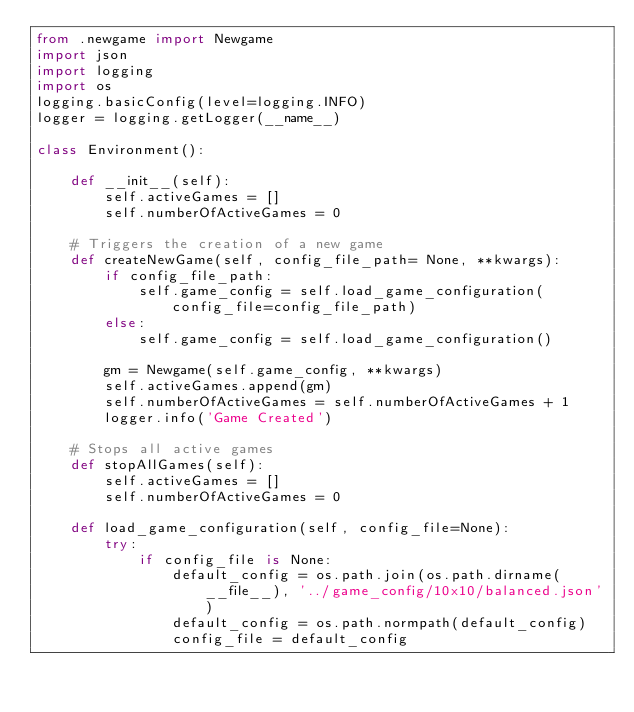Convert code to text. <code><loc_0><loc_0><loc_500><loc_500><_Python_>from .newgame import Newgame
import json
import logging
import os 
logging.basicConfig(level=logging.INFO)
logger = logging.getLogger(__name__)

class Environment():

    def __init__(self):
        self.activeGames = []
        self.numberOfActiveGames = 0

    # Triggers the creation of a new game
    def createNewGame(self, config_file_path= None, **kwargs):
        if config_file_path:
            self.game_config = self.load_game_configuration( config_file=config_file_path)
        else:
            self.game_config = self.load_game_configuration()

        gm = Newgame(self.game_config, **kwargs)
        self.activeGames.append(gm)
        self.numberOfActiveGames = self.numberOfActiveGames + 1
        logger.info('Game Created')

    # Stops all active games
    def stopAllGames(self):
        self.activeGames = []
        self.numberOfActiveGames = 0

    def load_game_configuration(self, config_file=None):
        try:
            if config_file is None:
                default_config = os.path.join(os.path.dirname(__file__), '../game_config/10x10/balanced.json')
                default_config = os.path.normpath(default_config)
                config_file = default_config</code> 